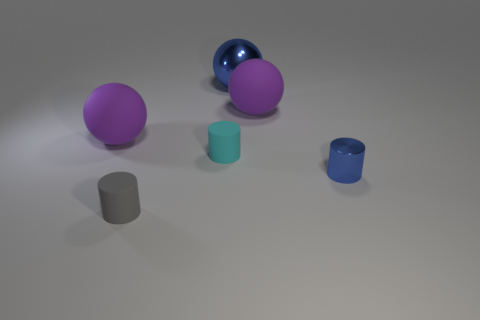Subtract all tiny cyan cylinders. How many cylinders are left? 2 Add 3 large blue shiny objects. How many objects exist? 9 Subtract all blue cylinders. How many cylinders are left? 2 Subtract 1 balls. How many balls are left? 2 Subtract all yellow balls. Subtract all yellow cylinders. How many balls are left? 3 Subtract all blue cylinders. How many green balls are left? 0 Subtract all blue cylinders. Subtract all shiny cylinders. How many objects are left? 4 Add 3 cyan objects. How many cyan objects are left? 4 Add 5 metal cylinders. How many metal cylinders exist? 6 Subtract 0 green blocks. How many objects are left? 6 